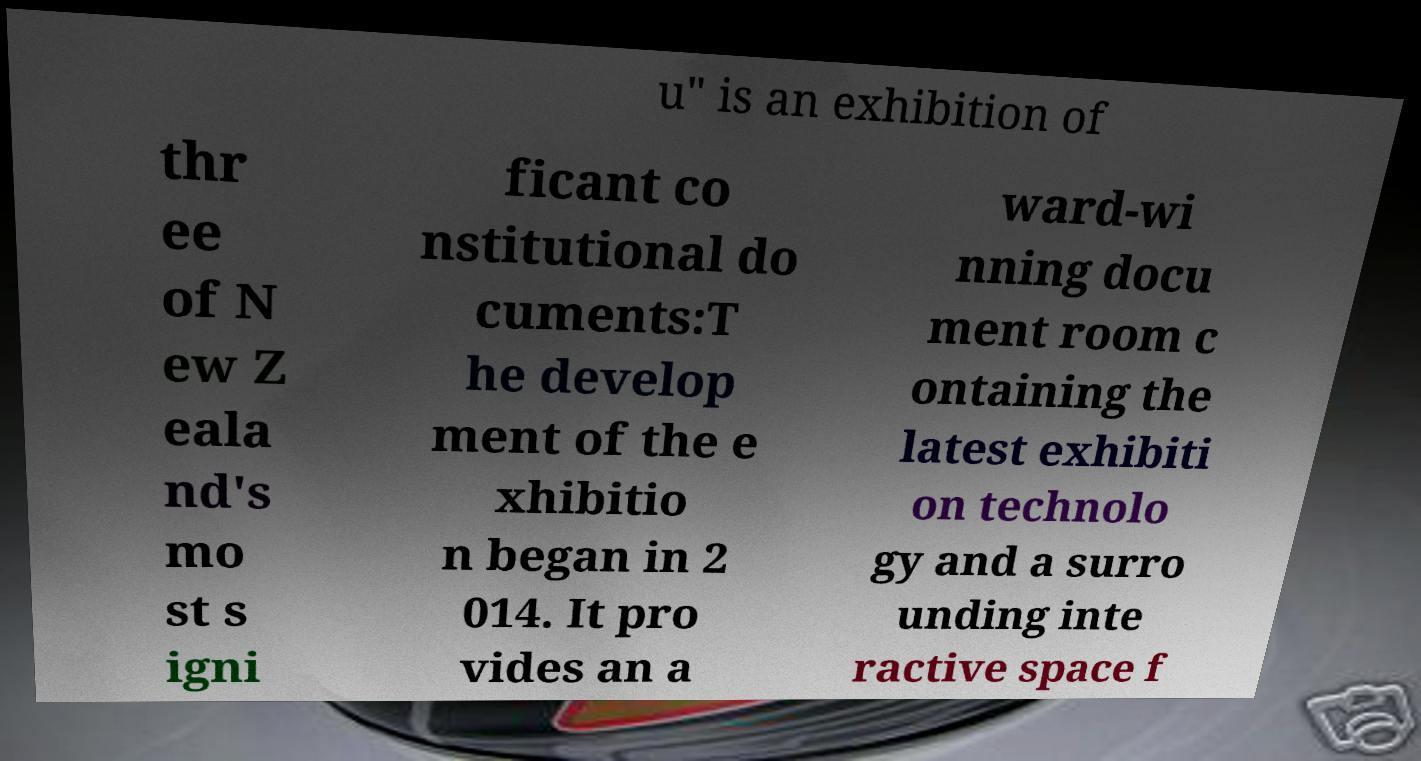I need the written content from this picture converted into text. Can you do that? u" is an exhibition of thr ee of N ew Z eala nd's mo st s igni ficant co nstitutional do cuments:T he develop ment of the e xhibitio n began in 2 014. It pro vides an a ward-wi nning docu ment room c ontaining the latest exhibiti on technolo gy and a surro unding inte ractive space f 